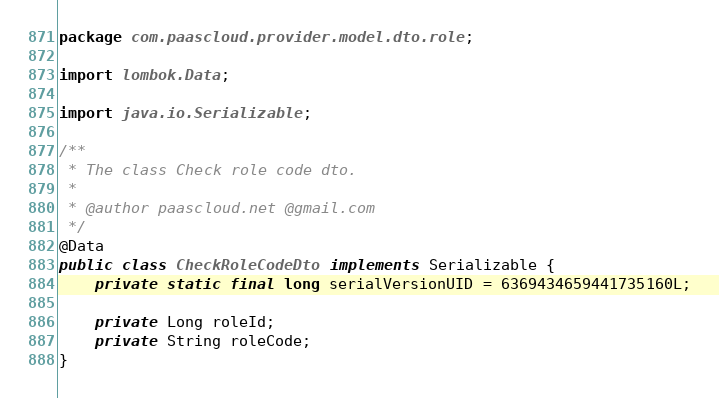Convert code to text. <code><loc_0><loc_0><loc_500><loc_500><_Java_>package com.paascloud.provider.model.dto.role;

import lombok.Data;

import java.io.Serializable;

/**
 * The class Check role code dto.
 *
 * @author paascloud.net @gmail.com
 */
@Data
public class CheckRoleCodeDto implements Serializable {
	private static final long serialVersionUID = 6369434659441735160L;

	private Long roleId;
	private String roleCode;
}
</code> 